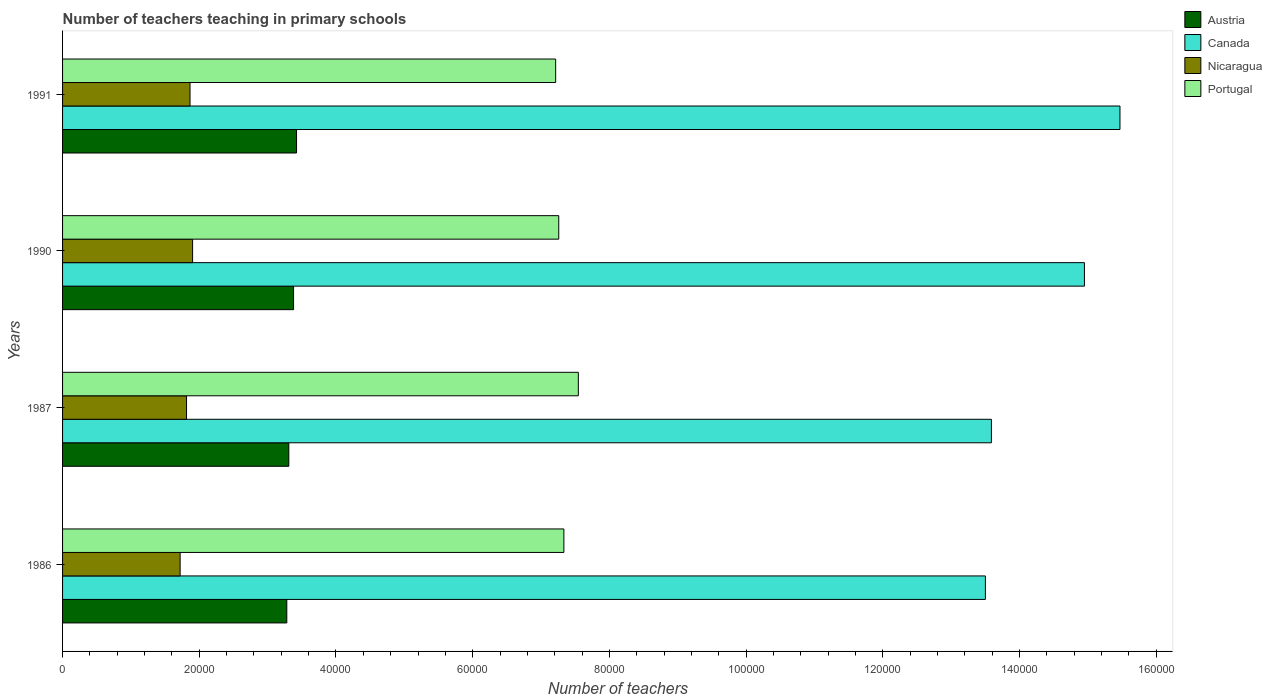How many groups of bars are there?
Your answer should be very brief. 4. Are the number of bars per tick equal to the number of legend labels?
Provide a succinct answer. Yes. Are the number of bars on each tick of the Y-axis equal?
Make the answer very short. Yes. How many bars are there on the 1st tick from the top?
Provide a succinct answer. 4. How many bars are there on the 4th tick from the bottom?
Your answer should be compact. 4. In how many cases, is the number of bars for a given year not equal to the number of legend labels?
Ensure brevity in your answer.  0. What is the number of teachers teaching in primary schools in Canada in 1986?
Keep it short and to the point. 1.35e+05. Across all years, what is the maximum number of teachers teaching in primary schools in Nicaragua?
Provide a succinct answer. 1.90e+04. Across all years, what is the minimum number of teachers teaching in primary schools in Portugal?
Give a very brief answer. 7.21e+04. What is the total number of teachers teaching in primary schools in Portugal in the graph?
Offer a very short reply. 2.94e+05. What is the difference between the number of teachers teaching in primary schools in Austria in 1987 and that in 1990?
Give a very brief answer. -696. What is the difference between the number of teachers teaching in primary schools in Portugal in 1991 and the number of teachers teaching in primary schools in Canada in 1986?
Offer a terse response. -6.29e+04. What is the average number of teachers teaching in primary schools in Portugal per year?
Provide a succinct answer. 7.34e+04. In the year 1990, what is the difference between the number of teachers teaching in primary schools in Nicaragua and number of teachers teaching in primary schools in Portugal?
Provide a succinct answer. -5.36e+04. What is the ratio of the number of teachers teaching in primary schools in Canada in 1986 to that in 1987?
Your response must be concise. 0.99. Is the number of teachers teaching in primary schools in Austria in 1990 less than that in 1991?
Your answer should be compact. Yes. Is the difference between the number of teachers teaching in primary schools in Nicaragua in 1986 and 1990 greater than the difference between the number of teachers teaching in primary schools in Portugal in 1986 and 1990?
Offer a very short reply. No. What is the difference between the highest and the second highest number of teachers teaching in primary schools in Portugal?
Provide a succinct answer. 2113. What is the difference between the highest and the lowest number of teachers teaching in primary schools in Canada?
Offer a terse response. 1.97e+04. Is it the case that in every year, the sum of the number of teachers teaching in primary schools in Portugal and number of teachers teaching in primary schools in Nicaragua is greater than the sum of number of teachers teaching in primary schools in Austria and number of teachers teaching in primary schools in Canada?
Make the answer very short. No. What does the 2nd bar from the top in 1991 represents?
Offer a terse response. Nicaragua. What does the 3rd bar from the bottom in 1987 represents?
Provide a succinct answer. Nicaragua. Is it the case that in every year, the sum of the number of teachers teaching in primary schools in Portugal and number of teachers teaching in primary schools in Canada is greater than the number of teachers teaching in primary schools in Austria?
Your answer should be compact. Yes. Are all the bars in the graph horizontal?
Your answer should be compact. Yes. Are the values on the major ticks of X-axis written in scientific E-notation?
Give a very brief answer. No. Does the graph contain any zero values?
Keep it short and to the point. No. Where does the legend appear in the graph?
Make the answer very short. Top right. How are the legend labels stacked?
Provide a short and direct response. Vertical. What is the title of the graph?
Your answer should be very brief. Number of teachers teaching in primary schools. What is the label or title of the X-axis?
Offer a very short reply. Number of teachers. What is the Number of teachers in Austria in 1986?
Keep it short and to the point. 3.28e+04. What is the Number of teachers in Canada in 1986?
Provide a succinct answer. 1.35e+05. What is the Number of teachers of Nicaragua in 1986?
Offer a terse response. 1.72e+04. What is the Number of teachers of Portugal in 1986?
Provide a short and direct response. 7.33e+04. What is the Number of teachers in Austria in 1987?
Offer a very short reply. 3.31e+04. What is the Number of teachers of Canada in 1987?
Your response must be concise. 1.36e+05. What is the Number of teachers of Nicaragua in 1987?
Give a very brief answer. 1.81e+04. What is the Number of teachers in Portugal in 1987?
Offer a very short reply. 7.55e+04. What is the Number of teachers in Austria in 1990?
Your answer should be very brief. 3.38e+04. What is the Number of teachers of Canada in 1990?
Keep it short and to the point. 1.50e+05. What is the Number of teachers of Nicaragua in 1990?
Give a very brief answer. 1.90e+04. What is the Number of teachers of Portugal in 1990?
Provide a succinct answer. 7.26e+04. What is the Number of teachers in Austria in 1991?
Provide a short and direct response. 3.42e+04. What is the Number of teachers of Canada in 1991?
Provide a short and direct response. 1.55e+05. What is the Number of teachers in Nicaragua in 1991?
Give a very brief answer. 1.86e+04. What is the Number of teachers of Portugal in 1991?
Ensure brevity in your answer.  7.21e+04. Across all years, what is the maximum Number of teachers in Austria?
Give a very brief answer. 3.42e+04. Across all years, what is the maximum Number of teachers of Canada?
Provide a succinct answer. 1.55e+05. Across all years, what is the maximum Number of teachers of Nicaragua?
Give a very brief answer. 1.90e+04. Across all years, what is the maximum Number of teachers of Portugal?
Ensure brevity in your answer.  7.55e+04. Across all years, what is the minimum Number of teachers of Austria?
Keep it short and to the point. 3.28e+04. Across all years, what is the minimum Number of teachers of Canada?
Provide a succinct answer. 1.35e+05. Across all years, what is the minimum Number of teachers of Nicaragua?
Your answer should be very brief. 1.72e+04. Across all years, what is the minimum Number of teachers in Portugal?
Ensure brevity in your answer.  7.21e+04. What is the total Number of teachers in Austria in the graph?
Provide a succinct answer. 1.34e+05. What is the total Number of teachers in Canada in the graph?
Your answer should be compact. 5.75e+05. What is the total Number of teachers in Nicaragua in the graph?
Provide a short and direct response. 7.30e+04. What is the total Number of teachers in Portugal in the graph?
Your answer should be compact. 2.94e+05. What is the difference between the Number of teachers in Austria in 1986 and that in 1987?
Provide a short and direct response. -294. What is the difference between the Number of teachers in Canada in 1986 and that in 1987?
Provide a short and direct response. -880. What is the difference between the Number of teachers of Nicaragua in 1986 and that in 1987?
Make the answer very short. -938. What is the difference between the Number of teachers of Portugal in 1986 and that in 1987?
Your answer should be compact. -2113. What is the difference between the Number of teachers in Austria in 1986 and that in 1990?
Give a very brief answer. -990. What is the difference between the Number of teachers in Canada in 1986 and that in 1990?
Provide a succinct answer. -1.45e+04. What is the difference between the Number of teachers in Nicaragua in 1986 and that in 1990?
Offer a terse response. -1823. What is the difference between the Number of teachers in Portugal in 1986 and that in 1990?
Provide a succinct answer. 750. What is the difference between the Number of teachers in Austria in 1986 and that in 1991?
Your answer should be compact. -1426. What is the difference between the Number of teachers in Canada in 1986 and that in 1991?
Keep it short and to the point. -1.97e+04. What is the difference between the Number of teachers of Nicaragua in 1986 and that in 1991?
Keep it short and to the point. -1447. What is the difference between the Number of teachers of Portugal in 1986 and that in 1991?
Ensure brevity in your answer.  1203. What is the difference between the Number of teachers in Austria in 1987 and that in 1990?
Make the answer very short. -696. What is the difference between the Number of teachers of Canada in 1987 and that in 1990?
Ensure brevity in your answer.  -1.36e+04. What is the difference between the Number of teachers of Nicaragua in 1987 and that in 1990?
Give a very brief answer. -885. What is the difference between the Number of teachers in Portugal in 1987 and that in 1990?
Keep it short and to the point. 2863. What is the difference between the Number of teachers of Austria in 1987 and that in 1991?
Ensure brevity in your answer.  -1132. What is the difference between the Number of teachers in Canada in 1987 and that in 1991?
Offer a very short reply. -1.88e+04. What is the difference between the Number of teachers in Nicaragua in 1987 and that in 1991?
Offer a very short reply. -509. What is the difference between the Number of teachers in Portugal in 1987 and that in 1991?
Your response must be concise. 3316. What is the difference between the Number of teachers of Austria in 1990 and that in 1991?
Provide a short and direct response. -436. What is the difference between the Number of teachers in Canada in 1990 and that in 1991?
Give a very brief answer. -5198. What is the difference between the Number of teachers in Nicaragua in 1990 and that in 1991?
Give a very brief answer. 376. What is the difference between the Number of teachers of Portugal in 1990 and that in 1991?
Give a very brief answer. 453. What is the difference between the Number of teachers of Austria in 1986 and the Number of teachers of Canada in 1987?
Keep it short and to the point. -1.03e+05. What is the difference between the Number of teachers in Austria in 1986 and the Number of teachers in Nicaragua in 1987?
Provide a short and direct response. 1.47e+04. What is the difference between the Number of teachers of Austria in 1986 and the Number of teachers of Portugal in 1987?
Offer a very short reply. -4.26e+04. What is the difference between the Number of teachers in Canada in 1986 and the Number of teachers in Nicaragua in 1987?
Keep it short and to the point. 1.17e+05. What is the difference between the Number of teachers in Canada in 1986 and the Number of teachers in Portugal in 1987?
Provide a short and direct response. 5.96e+04. What is the difference between the Number of teachers in Nicaragua in 1986 and the Number of teachers in Portugal in 1987?
Provide a short and direct response. -5.83e+04. What is the difference between the Number of teachers of Austria in 1986 and the Number of teachers of Canada in 1990?
Offer a terse response. -1.17e+05. What is the difference between the Number of teachers in Austria in 1986 and the Number of teachers in Nicaragua in 1990?
Offer a terse response. 1.38e+04. What is the difference between the Number of teachers in Austria in 1986 and the Number of teachers in Portugal in 1990?
Keep it short and to the point. -3.98e+04. What is the difference between the Number of teachers of Canada in 1986 and the Number of teachers of Nicaragua in 1990?
Provide a short and direct response. 1.16e+05. What is the difference between the Number of teachers of Canada in 1986 and the Number of teachers of Portugal in 1990?
Your response must be concise. 6.24e+04. What is the difference between the Number of teachers in Nicaragua in 1986 and the Number of teachers in Portugal in 1990?
Keep it short and to the point. -5.54e+04. What is the difference between the Number of teachers in Austria in 1986 and the Number of teachers in Canada in 1991?
Make the answer very short. -1.22e+05. What is the difference between the Number of teachers in Austria in 1986 and the Number of teachers in Nicaragua in 1991?
Keep it short and to the point. 1.42e+04. What is the difference between the Number of teachers of Austria in 1986 and the Number of teachers of Portugal in 1991?
Your response must be concise. -3.93e+04. What is the difference between the Number of teachers of Canada in 1986 and the Number of teachers of Nicaragua in 1991?
Make the answer very short. 1.16e+05. What is the difference between the Number of teachers of Canada in 1986 and the Number of teachers of Portugal in 1991?
Offer a very short reply. 6.29e+04. What is the difference between the Number of teachers of Nicaragua in 1986 and the Number of teachers of Portugal in 1991?
Provide a short and direct response. -5.49e+04. What is the difference between the Number of teachers of Austria in 1987 and the Number of teachers of Canada in 1990?
Your response must be concise. -1.16e+05. What is the difference between the Number of teachers in Austria in 1987 and the Number of teachers in Nicaragua in 1990?
Provide a short and direct response. 1.41e+04. What is the difference between the Number of teachers of Austria in 1987 and the Number of teachers of Portugal in 1990?
Your answer should be compact. -3.95e+04. What is the difference between the Number of teachers in Canada in 1987 and the Number of teachers in Nicaragua in 1990?
Provide a short and direct response. 1.17e+05. What is the difference between the Number of teachers of Canada in 1987 and the Number of teachers of Portugal in 1990?
Your response must be concise. 6.33e+04. What is the difference between the Number of teachers in Nicaragua in 1987 and the Number of teachers in Portugal in 1990?
Offer a very short reply. -5.45e+04. What is the difference between the Number of teachers in Austria in 1987 and the Number of teachers in Canada in 1991?
Offer a terse response. -1.22e+05. What is the difference between the Number of teachers in Austria in 1987 and the Number of teachers in Nicaragua in 1991?
Give a very brief answer. 1.45e+04. What is the difference between the Number of teachers of Austria in 1987 and the Number of teachers of Portugal in 1991?
Make the answer very short. -3.90e+04. What is the difference between the Number of teachers of Canada in 1987 and the Number of teachers of Nicaragua in 1991?
Make the answer very short. 1.17e+05. What is the difference between the Number of teachers in Canada in 1987 and the Number of teachers in Portugal in 1991?
Your answer should be very brief. 6.38e+04. What is the difference between the Number of teachers of Nicaragua in 1987 and the Number of teachers of Portugal in 1991?
Provide a short and direct response. -5.40e+04. What is the difference between the Number of teachers of Austria in 1990 and the Number of teachers of Canada in 1991?
Make the answer very short. -1.21e+05. What is the difference between the Number of teachers in Austria in 1990 and the Number of teachers in Nicaragua in 1991?
Your answer should be compact. 1.52e+04. What is the difference between the Number of teachers in Austria in 1990 and the Number of teachers in Portugal in 1991?
Ensure brevity in your answer.  -3.83e+04. What is the difference between the Number of teachers in Canada in 1990 and the Number of teachers in Nicaragua in 1991?
Provide a short and direct response. 1.31e+05. What is the difference between the Number of teachers of Canada in 1990 and the Number of teachers of Portugal in 1991?
Give a very brief answer. 7.74e+04. What is the difference between the Number of teachers in Nicaragua in 1990 and the Number of teachers in Portugal in 1991?
Make the answer very short. -5.31e+04. What is the average Number of teachers of Austria per year?
Give a very brief answer. 3.35e+04. What is the average Number of teachers in Canada per year?
Keep it short and to the point. 1.44e+05. What is the average Number of teachers in Nicaragua per year?
Your response must be concise. 1.83e+04. What is the average Number of teachers in Portugal per year?
Give a very brief answer. 7.34e+04. In the year 1986, what is the difference between the Number of teachers of Austria and Number of teachers of Canada?
Your response must be concise. -1.02e+05. In the year 1986, what is the difference between the Number of teachers of Austria and Number of teachers of Nicaragua?
Your response must be concise. 1.56e+04. In the year 1986, what is the difference between the Number of teachers in Austria and Number of teachers in Portugal?
Offer a terse response. -4.05e+04. In the year 1986, what is the difference between the Number of teachers in Canada and Number of teachers in Nicaragua?
Ensure brevity in your answer.  1.18e+05. In the year 1986, what is the difference between the Number of teachers of Canada and Number of teachers of Portugal?
Your answer should be compact. 6.17e+04. In the year 1986, what is the difference between the Number of teachers of Nicaragua and Number of teachers of Portugal?
Provide a short and direct response. -5.61e+04. In the year 1987, what is the difference between the Number of teachers of Austria and Number of teachers of Canada?
Offer a terse response. -1.03e+05. In the year 1987, what is the difference between the Number of teachers of Austria and Number of teachers of Nicaragua?
Provide a short and direct response. 1.50e+04. In the year 1987, what is the difference between the Number of teachers in Austria and Number of teachers in Portugal?
Your answer should be compact. -4.24e+04. In the year 1987, what is the difference between the Number of teachers in Canada and Number of teachers in Nicaragua?
Provide a succinct answer. 1.18e+05. In the year 1987, what is the difference between the Number of teachers in Canada and Number of teachers in Portugal?
Keep it short and to the point. 6.04e+04. In the year 1987, what is the difference between the Number of teachers of Nicaragua and Number of teachers of Portugal?
Ensure brevity in your answer.  -5.73e+04. In the year 1990, what is the difference between the Number of teachers of Austria and Number of teachers of Canada?
Make the answer very short. -1.16e+05. In the year 1990, what is the difference between the Number of teachers of Austria and Number of teachers of Nicaragua?
Make the answer very short. 1.48e+04. In the year 1990, what is the difference between the Number of teachers of Austria and Number of teachers of Portugal?
Give a very brief answer. -3.88e+04. In the year 1990, what is the difference between the Number of teachers in Canada and Number of teachers in Nicaragua?
Offer a very short reply. 1.30e+05. In the year 1990, what is the difference between the Number of teachers of Canada and Number of teachers of Portugal?
Provide a succinct answer. 7.69e+04. In the year 1990, what is the difference between the Number of teachers of Nicaragua and Number of teachers of Portugal?
Make the answer very short. -5.36e+04. In the year 1991, what is the difference between the Number of teachers in Austria and Number of teachers in Canada?
Give a very brief answer. -1.20e+05. In the year 1991, what is the difference between the Number of teachers of Austria and Number of teachers of Nicaragua?
Provide a short and direct response. 1.56e+04. In the year 1991, what is the difference between the Number of teachers in Austria and Number of teachers in Portugal?
Offer a very short reply. -3.79e+04. In the year 1991, what is the difference between the Number of teachers of Canada and Number of teachers of Nicaragua?
Ensure brevity in your answer.  1.36e+05. In the year 1991, what is the difference between the Number of teachers in Canada and Number of teachers in Portugal?
Your answer should be very brief. 8.26e+04. In the year 1991, what is the difference between the Number of teachers of Nicaragua and Number of teachers of Portugal?
Your answer should be compact. -5.35e+04. What is the ratio of the Number of teachers of Austria in 1986 to that in 1987?
Offer a terse response. 0.99. What is the ratio of the Number of teachers in Nicaragua in 1986 to that in 1987?
Ensure brevity in your answer.  0.95. What is the ratio of the Number of teachers in Portugal in 1986 to that in 1987?
Offer a very short reply. 0.97. What is the ratio of the Number of teachers of Austria in 1986 to that in 1990?
Keep it short and to the point. 0.97. What is the ratio of the Number of teachers in Canada in 1986 to that in 1990?
Provide a succinct answer. 0.9. What is the ratio of the Number of teachers in Nicaragua in 1986 to that in 1990?
Offer a very short reply. 0.9. What is the ratio of the Number of teachers of Portugal in 1986 to that in 1990?
Provide a succinct answer. 1.01. What is the ratio of the Number of teachers in Canada in 1986 to that in 1991?
Keep it short and to the point. 0.87. What is the ratio of the Number of teachers of Nicaragua in 1986 to that in 1991?
Your answer should be very brief. 0.92. What is the ratio of the Number of teachers of Portugal in 1986 to that in 1991?
Provide a short and direct response. 1.02. What is the ratio of the Number of teachers of Austria in 1987 to that in 1990?
Give a very brief answer. 0.98. What is the ratio of the Number of teachers of Canada in 1987 to that in 1990?
Offer a terse response. 0.91. What is the ratio of the Number of teachers of Nicaragua in 1987 to that in 1990?
Make the answer very short. 0.95. What is the ratio of the Number of teachers of Portugal in 1987 to that in 1990?
Your answer should be very brief. 1.04. What is the ratio of the Number of teachers of Austria in 1987 to that in 1991?
Your answer should be compact. 0.97. What is the ratio of the Number of teachers of Canada in 1987 to that in 1991?
Provide a succinct answer. 0.88. What is the ratio of the Number of teachers of Nicaragua in 1987 to that in 1991?
Provide a succinct answer. 0.97. What is the ratio of the Number of teachers of Portugal in 1987 to that in 1991?
Offer a terse response. 1.05. What is the ratio of the Number of teachers in Austria in 1990 to that in 1991?
Keep it short and to the point. 0.99. What is the ratio of the Number of teachers in Canada in 1990 to that in 1991?
Your answer should be very brief. 0.97. What is the ratio of the Number of teachers of Nicaragua in 1990 to that in 1991?
Provide a short and direct response. 1.02. What is the ratio of the Number of teachers of Portugal in 1990 to that in 1991?
Keep it short and to the point. 1.01. What is the difference between the highest and the second highest Number of teachers in Austria?
Offer a terse response. 436. What is the difference between the highest and the second highest Number of teachers in Canada?
Make the answer very short. 5198. What is the difference between the highest and the second highest Number of teachers in Nicaragua?
Offer a terse response. 376. What is the difference between the highest and the second highest Number of teachers in Portugal?
Offer a very short reply. 2113. What is the difference between the highest and the lowest Number of teachers in Austria?
Ensure brevity in your answer.  1426. What is the difference between the highest and the lowest Number of teachers in Canada?
Give a very brief answer. 1.97e+04. What is the difference between the highest and the lowest Number of teachers of Nicaragua?
Offer a very short reply. 1823. What is the difference between the highest and the lowest Number of teachers in Portugal?
Provide a short and direct response. 3316. 